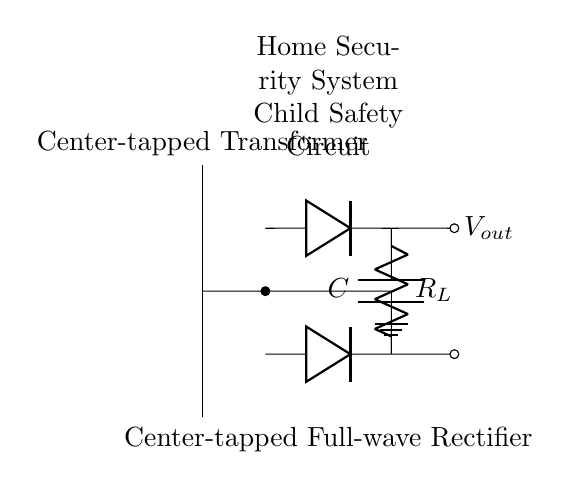What is the type of rectifier used in this circuit? The circuit specifically uses a center-tapped full-wave rectifier, indicated by the configuration of the diodes and transformer.
Answer: center-tapped full-wave rectifier What is the purpose of the capacitor in the circuit? The capacitor smooths the output voltage by reducing ripples after rectification, ensuring a more stable DC output for the security system.
Answer: smooth output voltage How many diodes are present in the circuit? The diagram clearly shows two diodes connected in parallel to the load resistor, used for full-wave rectification.
Answer: two What is the load resistor labeled as? The load resistor in the circuit diagram is labeled as R_L, which signifies its role in the system where the rectified output is utilized.
Answer: R_L How is the transformer connected in this circuit? The transformer is center-tapped and connected to both diodes, allowing the current to flow through each diode alternately, producing a full-wave output.
Answer: center-tapped 